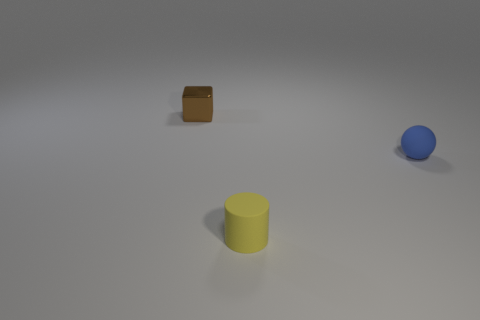How would you describe the lighting and shadows in this scene? The lighting in this scene appears to be coming from above, as indicated by the soft shadows located directly under and to the sides of the objects. The shadows are diffused, suggesting the light source is not extremely close to the objects, and is likely a broader or softer light, which decreases the hardness of the shadows. 